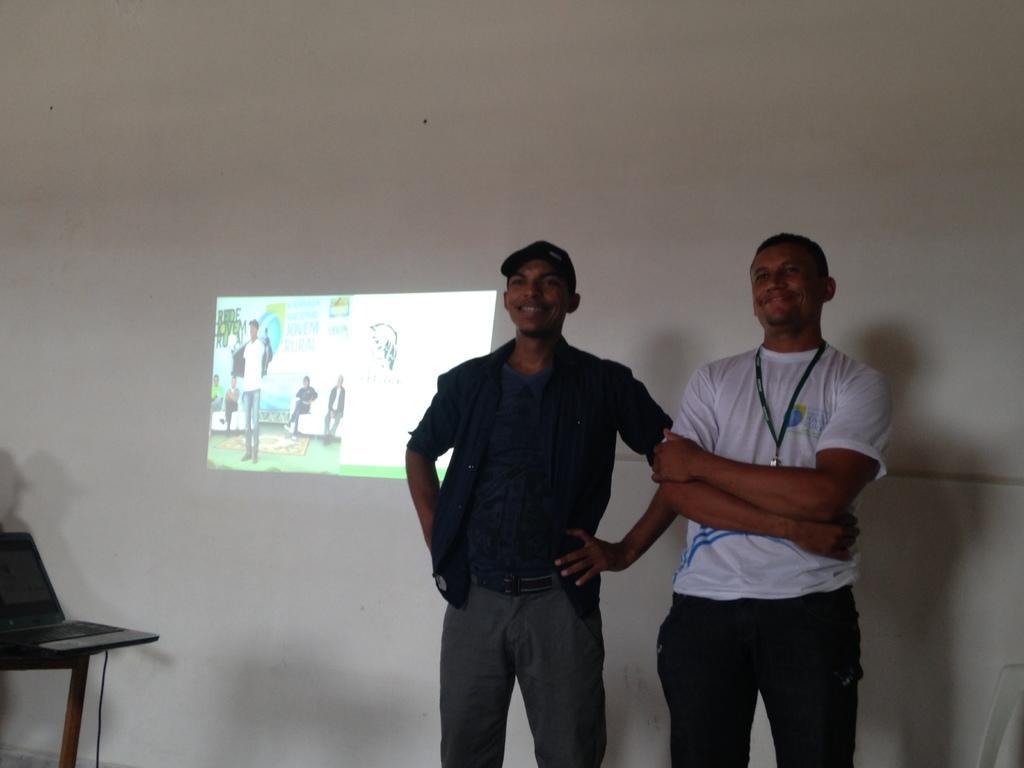How would you summarize this image in a sentence or two? In this image there are two persons,there is a white wall,there is a laptop on the table,there is a wire. 